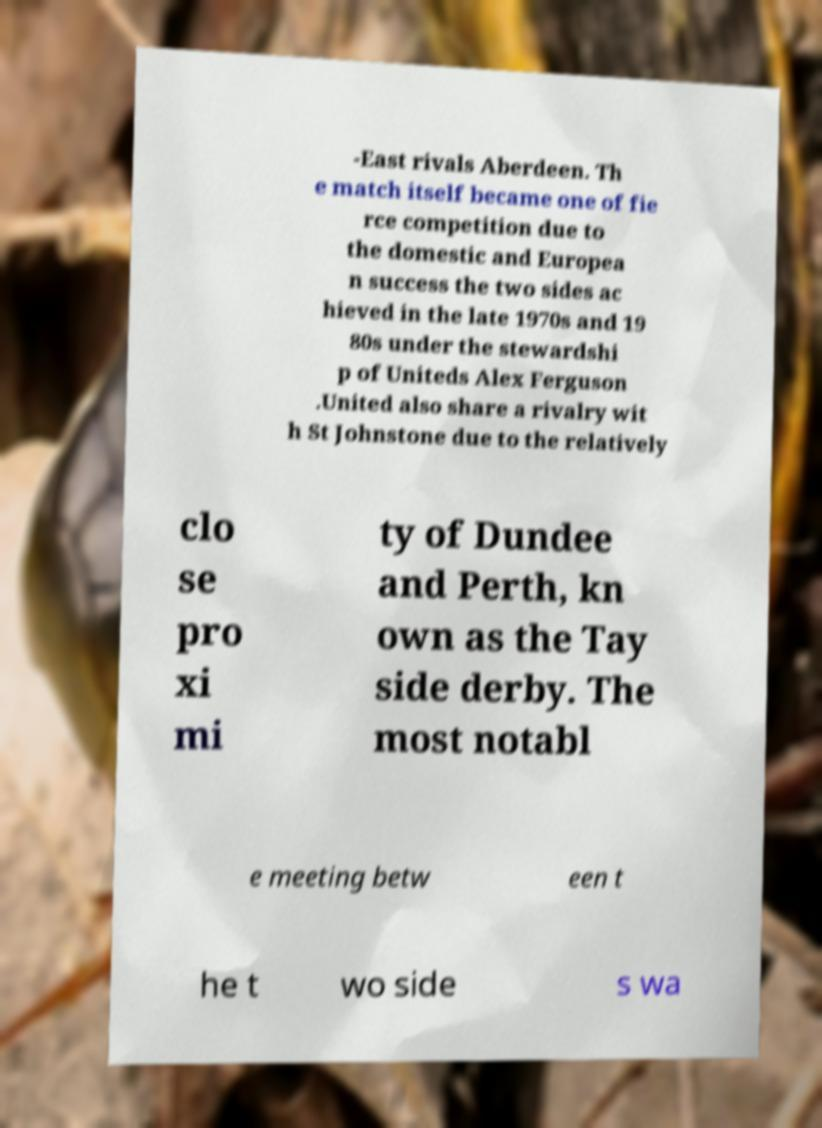For documentation purposes, I need the text within this image transcribed. Could you provide that? -East rivals Aberdeen. Th e match itself became one of fie rce competition due to the domestic and Europea n success the two sides ac hieved in the late 1970s and 19 80s under the stewardshi p of Uniteds Alex Ferguson .United also share a rivalry wit h St Johnstone due to the relatively clo se pro xi mi ty of Dundee and Perth, kn own as the Tay side derby. The most notabl e meeting betw een t he t wo side s wa 